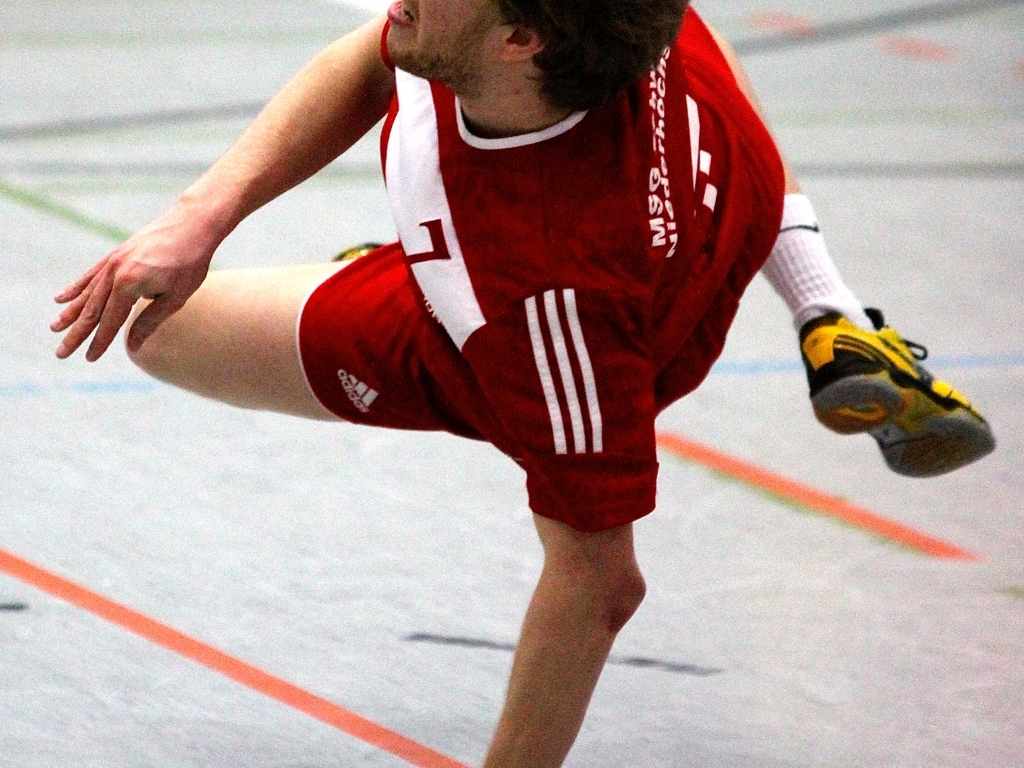Are there missing characters in this image? While it may appear there are missing characters due to the unusual crop of the image showing only a partial view of a person, it's actually a complete photograph capturing a moment in sports, likely highlighting a dynamic action. 